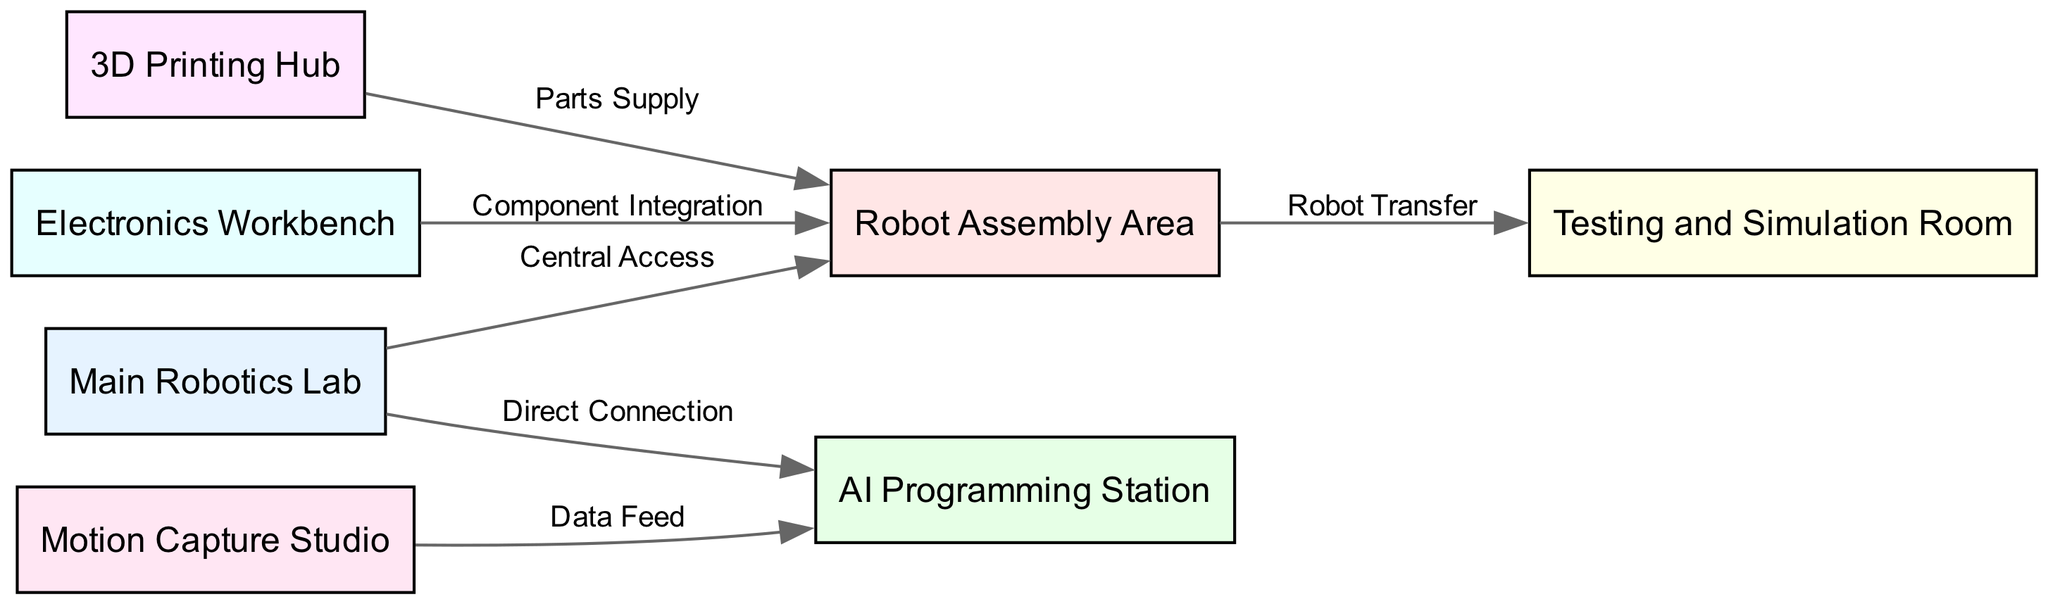What is the main area of the lab called? The diagram identifies the central workspace as "Main Robotics Lab," which is labeled as the overall area for various activities.
Answer: Main Robotics Lab How many workstations are there in the diagram? The diagram lists a total of six distinct workstations, each represented by a node.
Answer: 6 Which area has a direct connection to the AI Programming Station? The diagram shows that the "Main Robotics Lab" has a direct connection to the "AI Programming Station," indicating a clear path for workflow.
Answer: Main Robotics Lab What is the relationship between the Robot Assembly Area and the Testing and Simulation Room? The "Robot Assembly Area" transfers robots to the "Testing and Simulation Room," with a defined edge labeled "Robot Transfer."
Answer: Robot Transfer What supplies parts to the Robot Assembly Area? According to the diagram, the "3D Printing Hub" supplies parts directly to the "Robot Assembly Area."
Answer: Parts Supply Which workstation provides data feed to the AI Programming Station? The diagram specifies that the "Motion Capture Studio" is responsible for providing data feed to the "AI Programming Station," indicating an information flow.
Answer: Motion Capture Studio Which workbench is responsible for integrating components into the Robot Assembly Area? The "Electronics Workbench" is identified in the diagram as the workstation that integrates components into the "Robot Assembly Area."
Answer: Electronics Workbench What area connects directly to both the assembly area and the programming station? The "Main Robotics Lab" serves as a central hub, directly connecting both the "Robot Assembly Area" and "AI Programming Station," facilitating the interaction between these spaces.
Answer: Main Robotics Lab How many edges are present in the diagram? The connections or edges depicted in the diagram number six, connecting the various workstations.
Answer: 6 